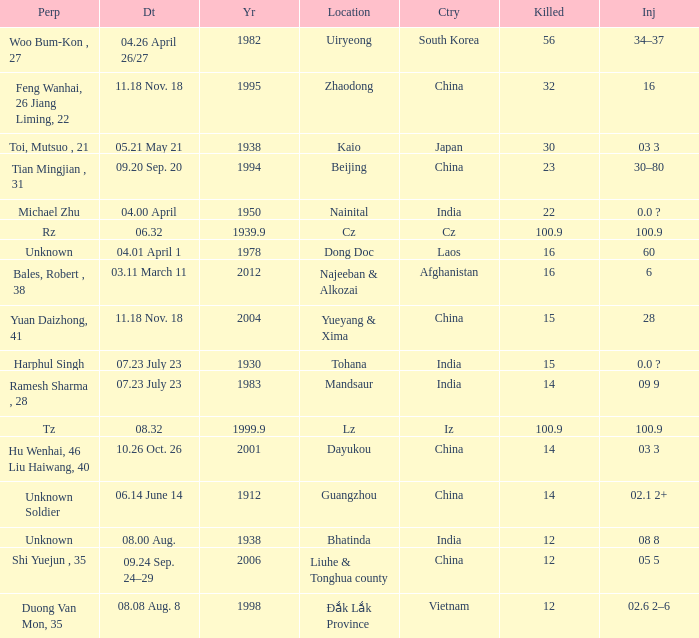01 april 1"? 1978.0. 